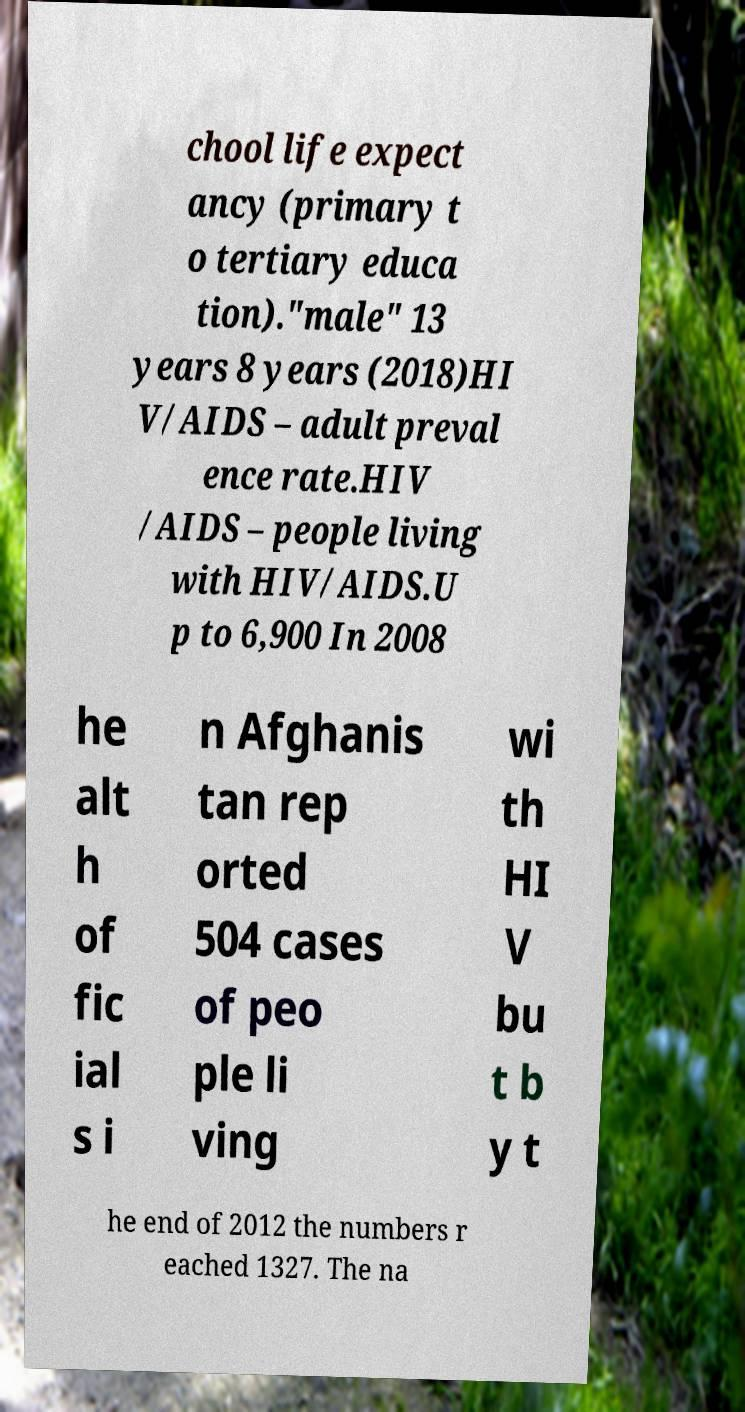I need the written content from this picture converted into text. Can you do that? chool life expect ancy (primary t o tertiary educa tion)."male" 13 years 8 years (2018)HI V/AIDS – adult preval ence rate.HIV /AIDS – people living with HIV/AIDS.U p to 6,900 In 2008 he alt h of fic ial s i n Afghanis tan rep orted 504 cases of peo ple li ving wi th HI V bu t b y t he end of 2012 the numbers r eached 1327. The na 